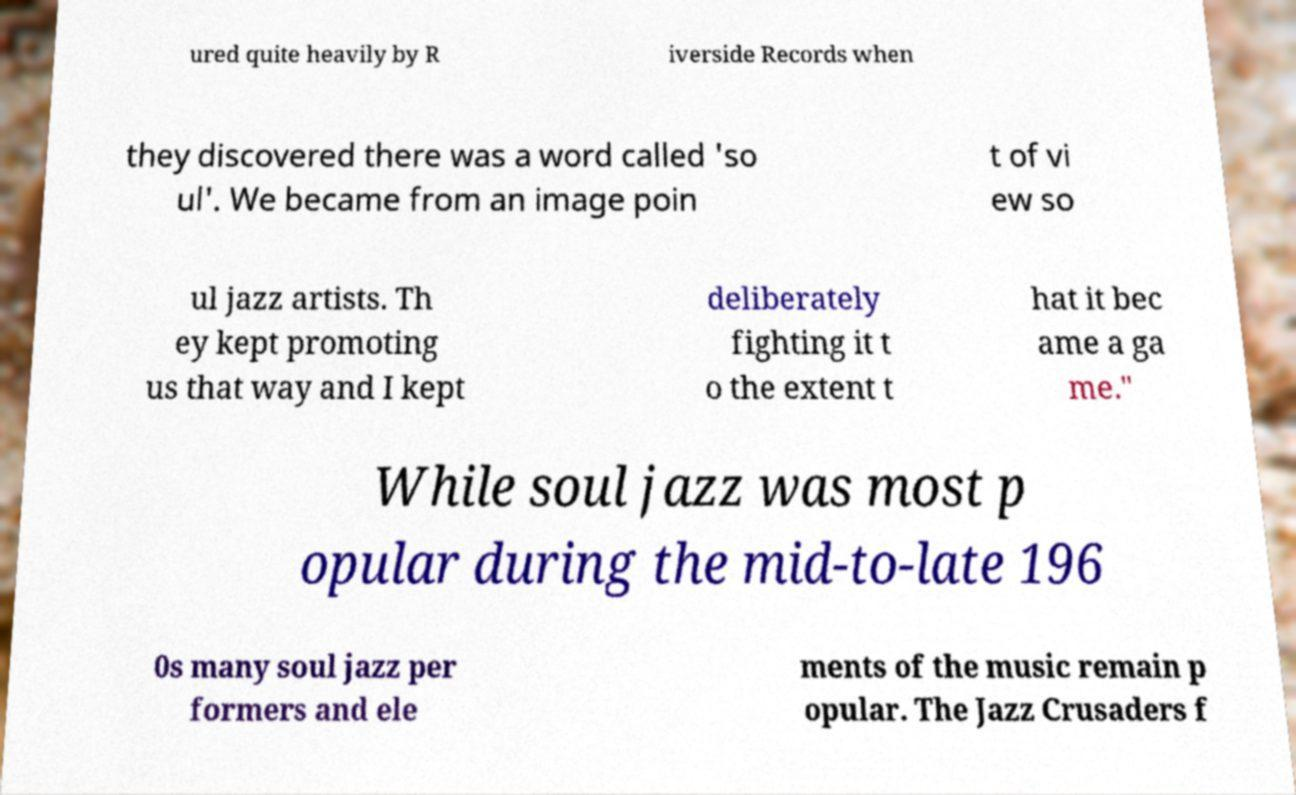Could you extract and type out the text from this image? ured quite heavily by R iverside Records when they discovered there was a word called 'so ul'. We became from an image poin t of vi ew so ul jazz artists. Th ey kept promoting us that way and I kept deliberately fighting it t o the extent t hat it bec ame a ga me." While soul jazz was most p opular during the mid-to-late 196 0s many soul jazz per formers and ele ments of the music remain p opular. The Jazz Crusaders f 